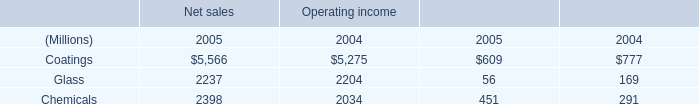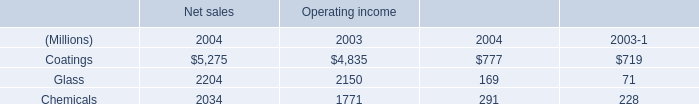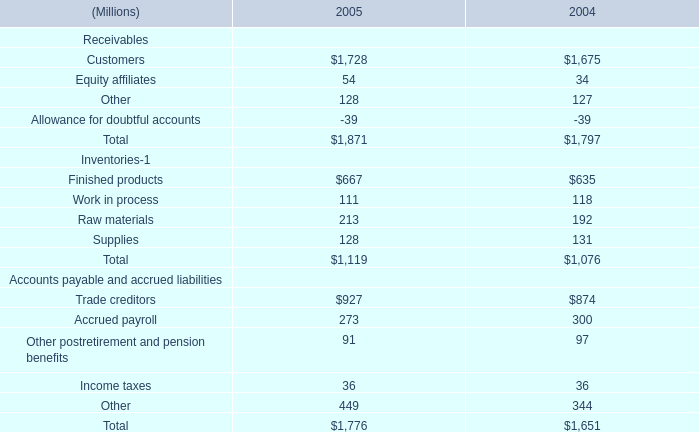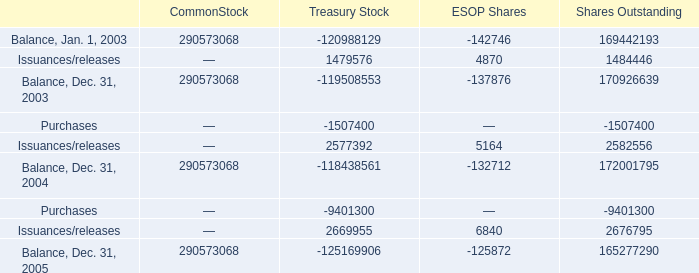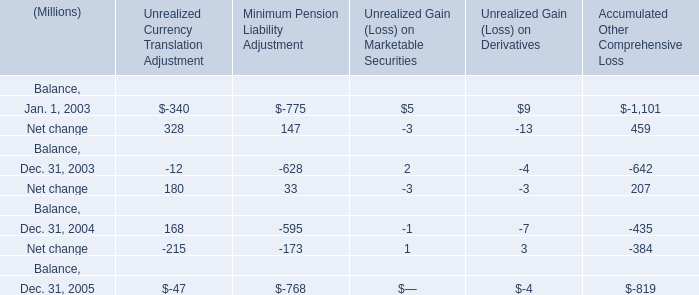What's the sum of Purchases of Treasury Stock, and Coatings of Net sales 2005 ? 
Computations: (1507400.0 + 5566.0)
Answer: 1512966.0. 